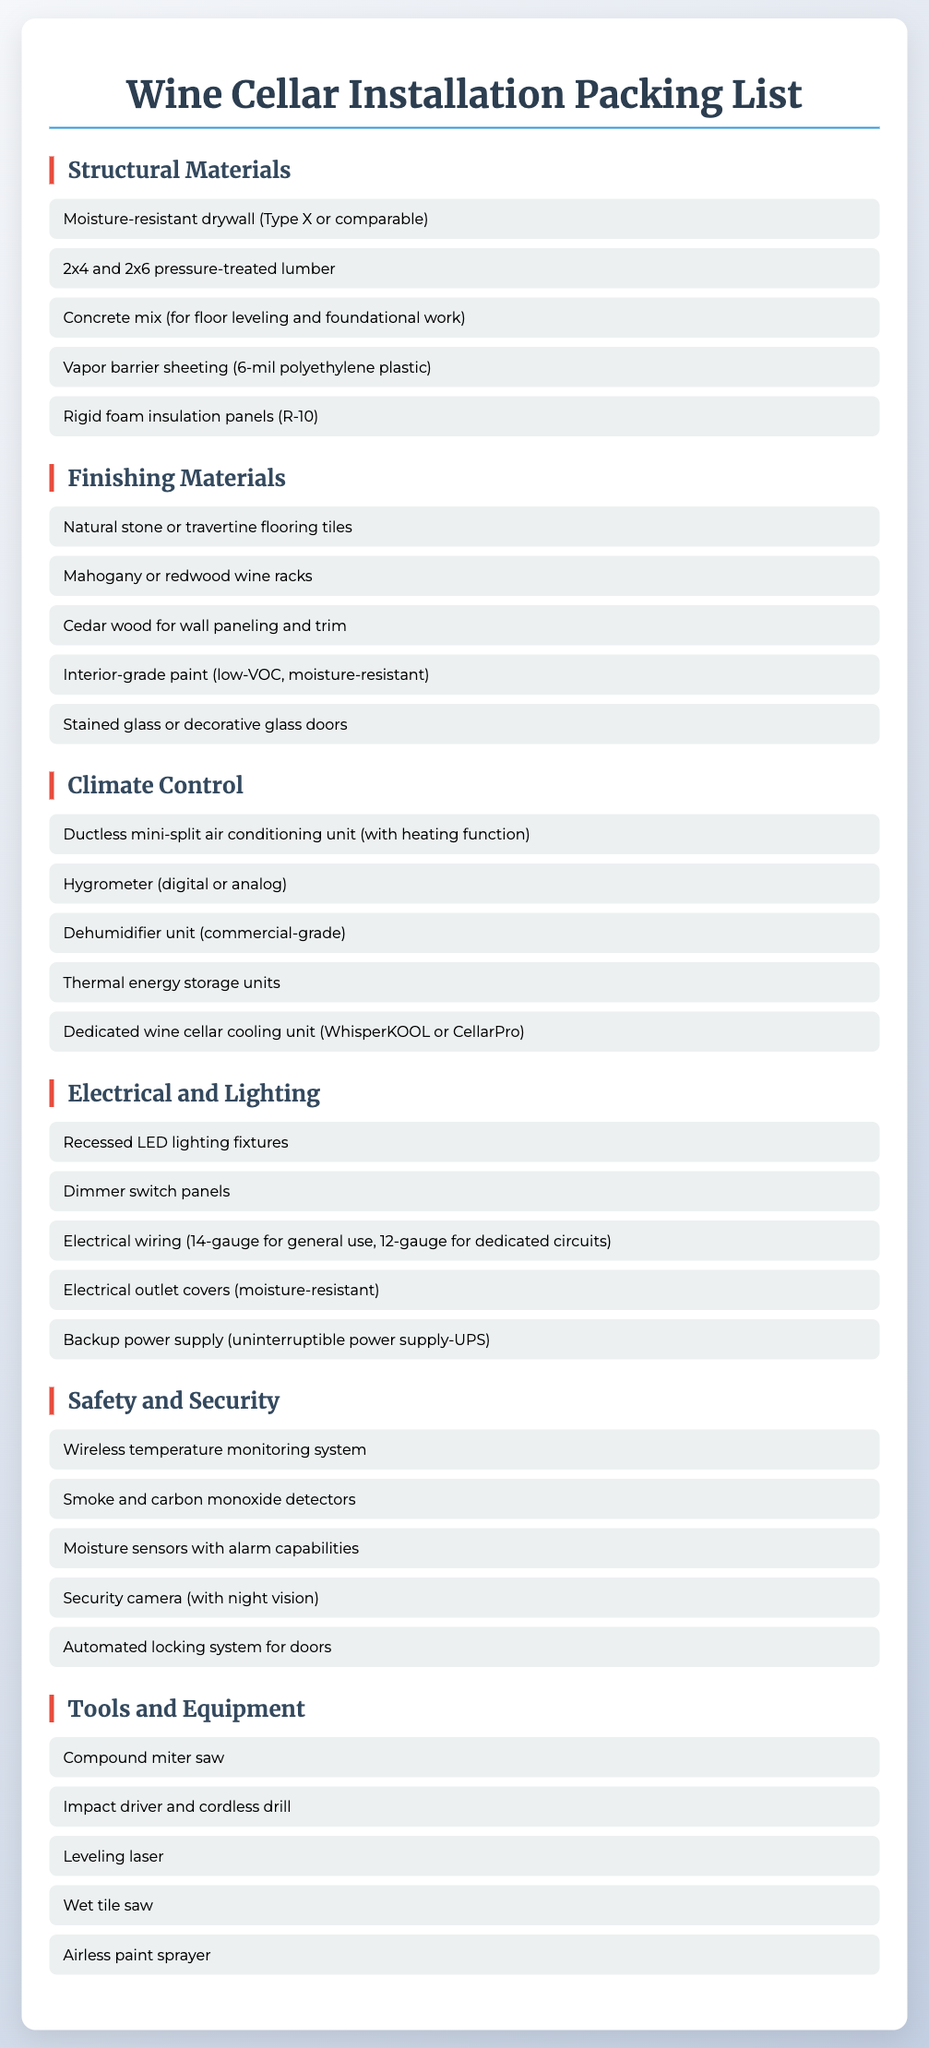What type of drywall is listed? The document specifies "moisture-resistant drywall (Type X or comparable)" in the Structural Materials section.
Answer: moisture-resistant drywall (Type X or comparable) How many types of flooring tiles are mentioned? The document lists only one type of flooring tile, which is "Natural stone or travertine flooring tiles" in the Finishing Materials section.
Answer: one What is the required insulation R-value? The document states that the rigid foam insulation panels should have "R-10" in the Structural Materials section.
Answer: R-10 Which type of air conditioning unit is recommended? The document specifies the "ductless mini-split air conditioning unit (with heating function)" in the Climate Control section.
Answer: ductless mini-split air conditioning unit (with heating function) What is a tool mentioned for painting? The document mentions "Airless paint sprayer" in the Tools and Equipment section as a tool for painting.
Answer: Airless paint sprayer How many safety/security items are listed? There are five items listed in the Safety and Security section, detailing different safety features for the wine cellar.
Answer: five What type of wine racks are recommended? The document refers to "Mahogany or redwood wine racks" in the Finishing Materials section for wine storage.
Answer: Mahogany or redwood wine racks What is one type of detector mentioned? The document highlights "Smoke and carbon monoxide detectors" under the Safety and Security section as an essential item.
Answer: Smoke and carbon monoxide detectors Which tool is specified for cutting tiles? The Tools and Equipment section includes "Wet tile saw" as a tool recommended for cutting tiles.
Answer: Wet tile saw 